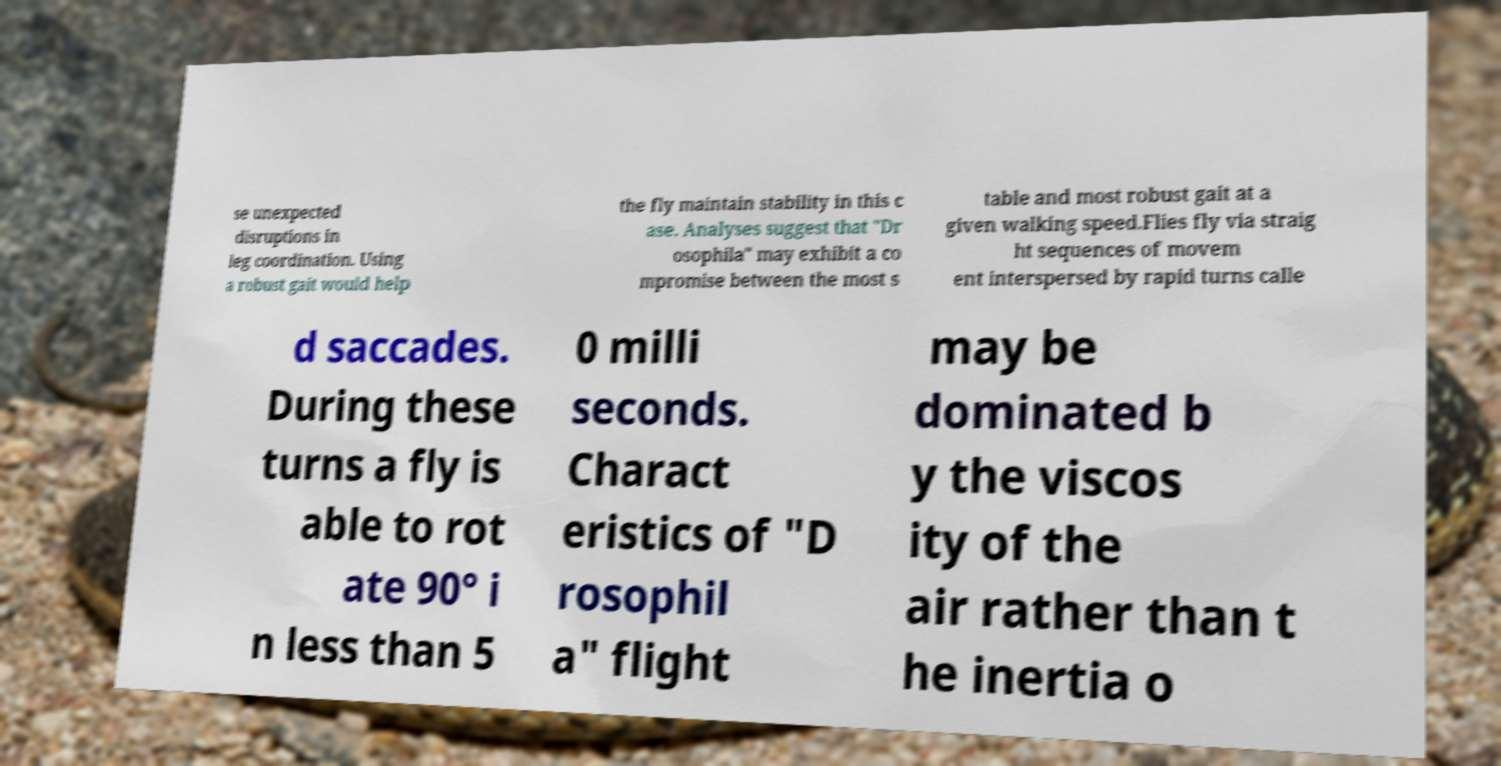There's text embedded in this image that I need extracted. Can you transcribe it verbatim? se unexpected disruptions in leg coordination. Using a robust gait would help the fly maintain stability in this c ase. Analyses suggest that "Dr osophila" may exhibit a co mpromise between the most s table and most robust gait at a given walking speed.Flies fly via straig ht sequences of movem ent interspersed by rapid turns calle d saccades. During these turns a fly is able to rot ate 90° i n less than 5 0 milli seconds. Charact eristics of "D rosophil a" flight may be dominated b y the viscos ity of the air rather than t he inertia o 